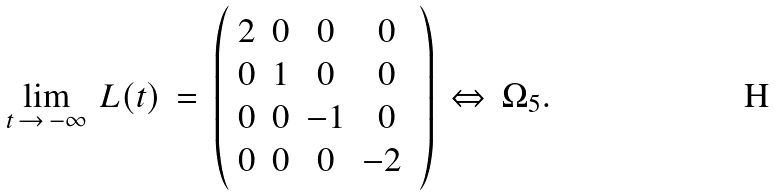Convert formula to latex. <formula><loc_0><loc_0><loc_500><loc_500>\lim _ { t \, \rightarrow \, - \infty } \, L ( t ) \, = \, \left ( \begin{array} { c c c c } 2 & 0 & 0 & 0 \\ 0 & 1 & 0 & 0 \\ 0 & 0 & - 1 & 0 \\ 0 & 0 & 0 & - 2 \ \end{array} \right ) \, \Leftrightarrow \, \Omega _ { 5 } .</formula> 